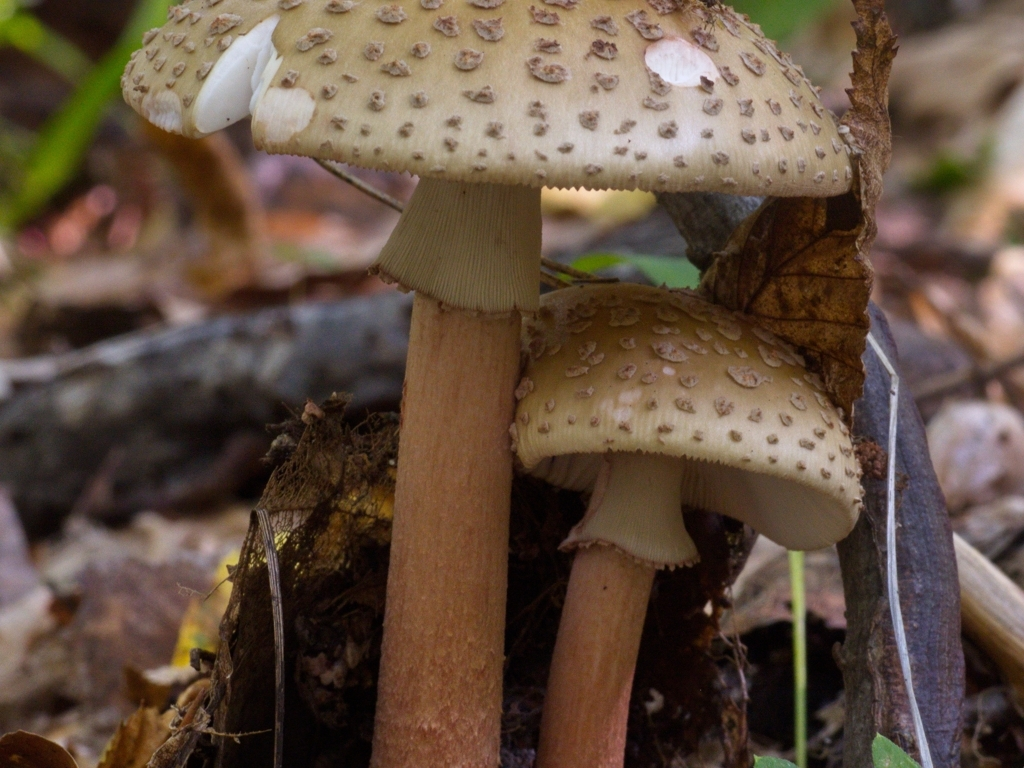Can you tell me more about the type of mushrooms these are? Certainly! While I cannot definitively identify the species without further context, these mushrooms appear to be of the genus Amanita, which are known for their spotted caps and white gills. It's important to note that many Amanita species are toxic, so they should never be consumed without proper identification from an expert. What can you say about their habitat? These mushrooms typically thrive in moist, wooded areas where they can form symbiotic relationships with the roots of trees. The presence of forest litter and fallen leaves in the image suggests a natural, undisturbed environment, which is ideal for fungal growth. 